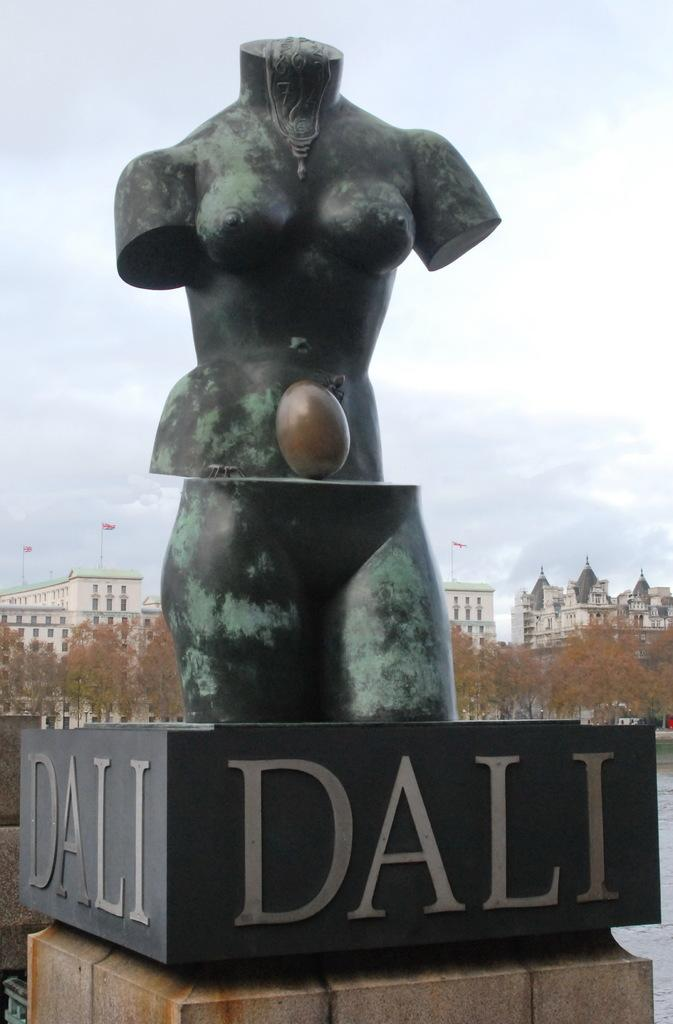What is the main subject in the image? There is a statue in the image. What can be seen in the background of the image? There are buildings, trees, and the sky visible in the background of the image. Are there any clouds in the sky? Yes, clouds are present in the sky. What type of toothbrush is the statue holding in the image? There is no toothbrush present in the image; the statue is not holding any object. 